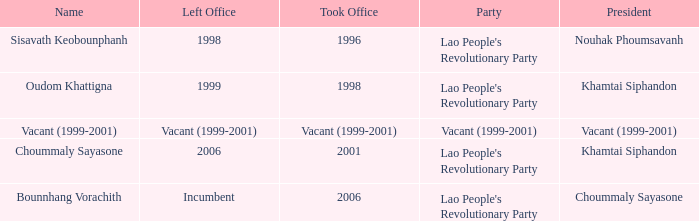What is Left Office, when Took Office is 1998? 1999.0. 